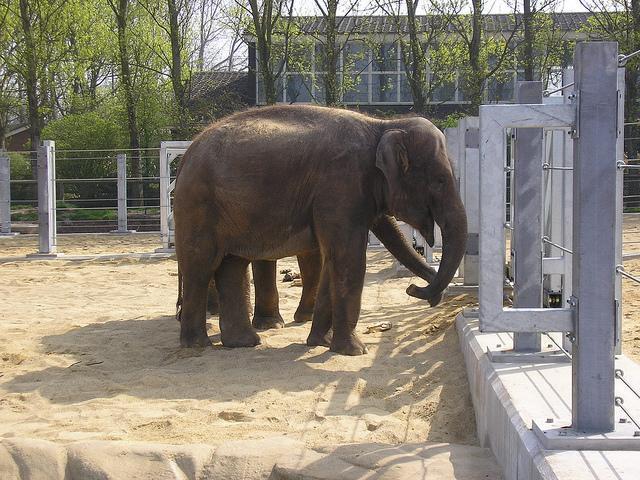How many animals can be seen?
Give a very brief answer. 2. How many elephants are there?
Give a very brief answer. 2. 